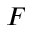<formula> <loc_0><loc_0><loc_500><loc_500>F</formula> 